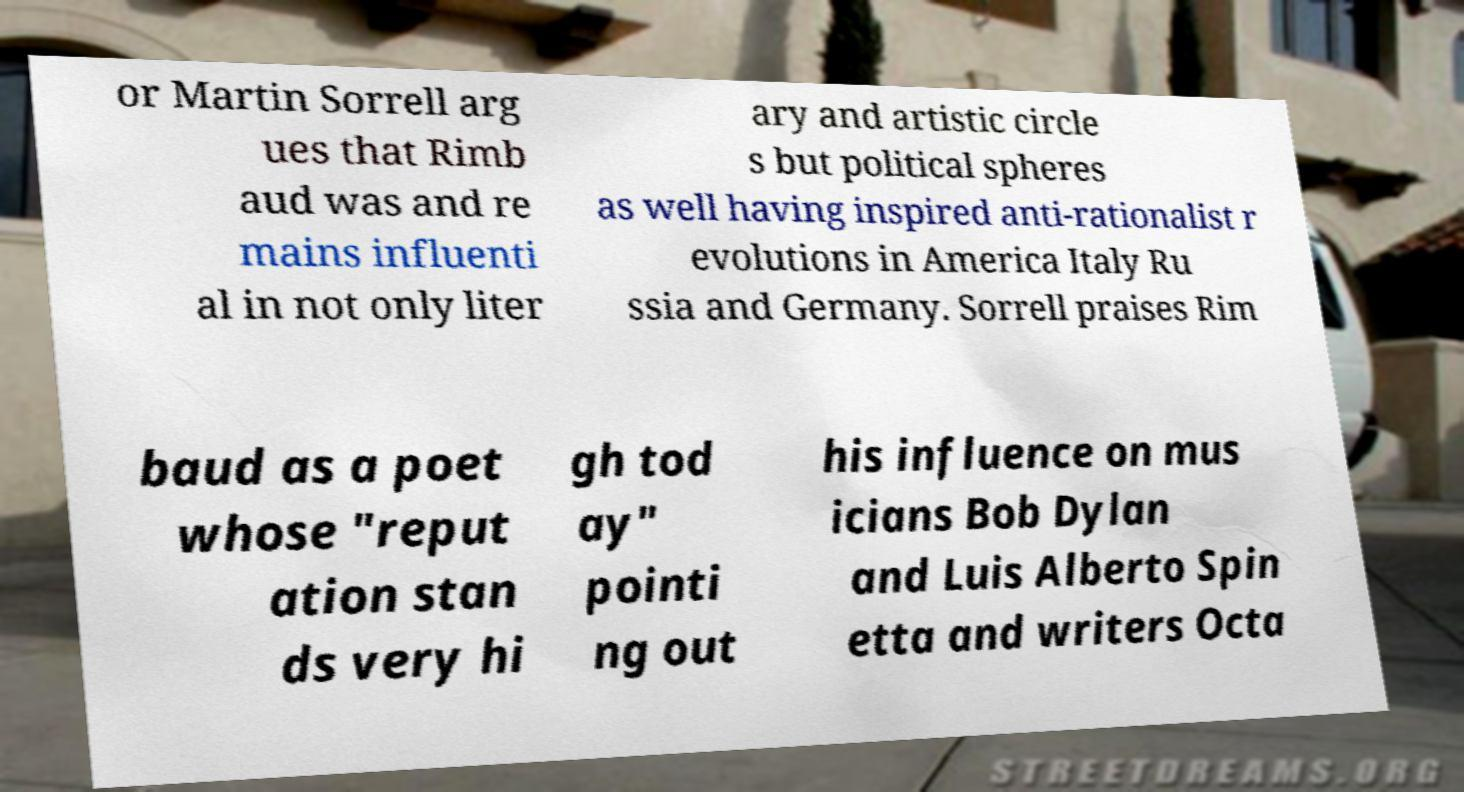There's text embedded in this image that I need extracted. Can you transcribe it verbatim? or Martin Sorrell arg ues that Rimb aud was and re mains influenti al in not only liter ary and artistic circle s but political spheres as well having inspired anti-rationalist r evolutions in America Italy Ru ssia and Germany. Sorrell praises Rim baud as a poet whose "reput ation stan ds very hi gh tod ay" pointi ng out his influence on mus icians Bob Dylan and Luis Alberto Spin etta and writers Octa 